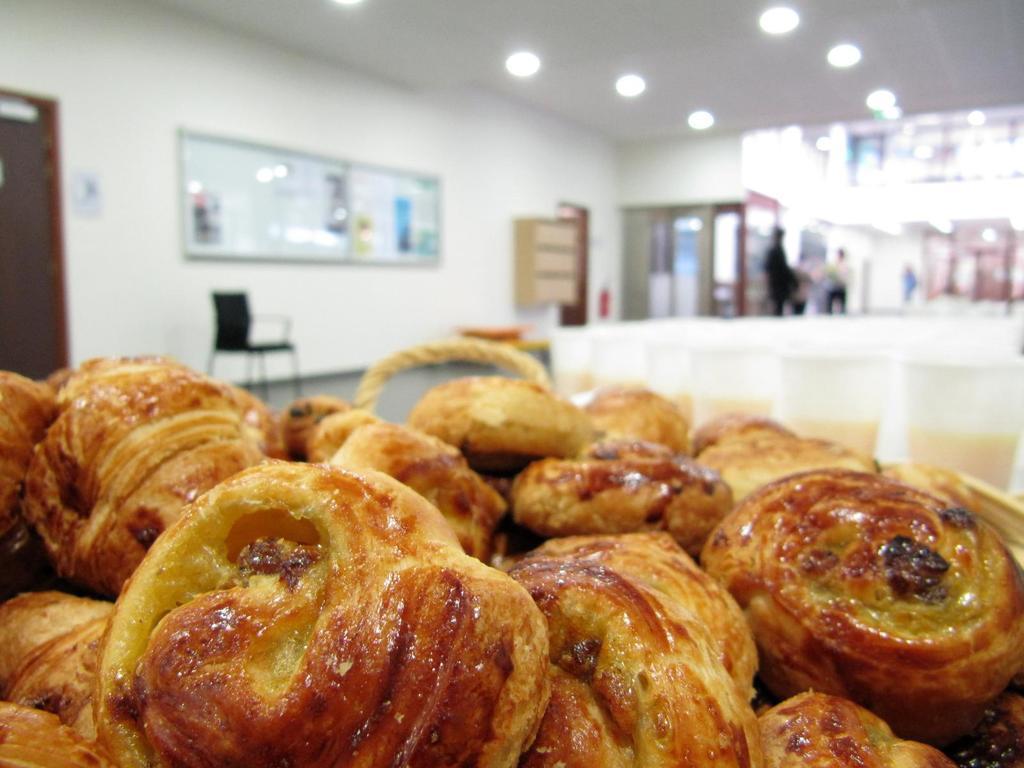Please provide a concise description of this image. In this image at the bottom there are some food items, and in the background there is a chair, boards, cupboards, lights and some people are standing. And there are some doors and wall, and on the right side of the image there are some glasses. In the glasses there is drink, at the top there is ceiling and lights. On the left side there is a door. 